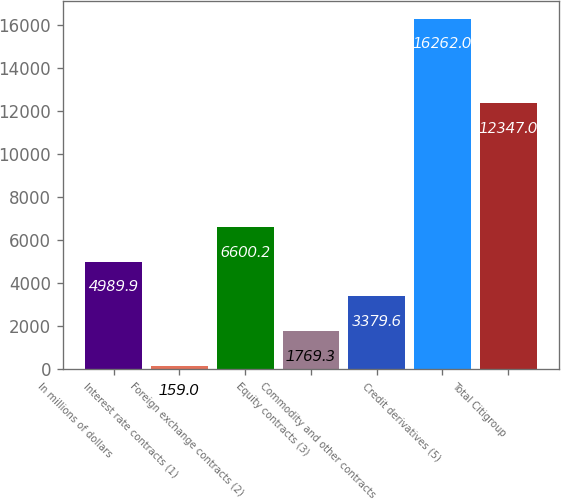Convert chart to OTSL. <chart><loc_0><loc_0><loc_500><loc_500><bar_chart><fcel>In millions of dollars<fcel>Interest rate contracts (1)<fcel>Foreign exchange contracts (2)<fcel>Equity contracts (3)<fcel>Commodity and other contracts<fcel>Credit derivatives (5)<fcel>Total Citigroup<nl><fcel>4989.9<fcel>159<fcel>6600.2<fcel>1769.3<fcel>3379.6<fcel>16262<fcel>12347<nl></chart> 